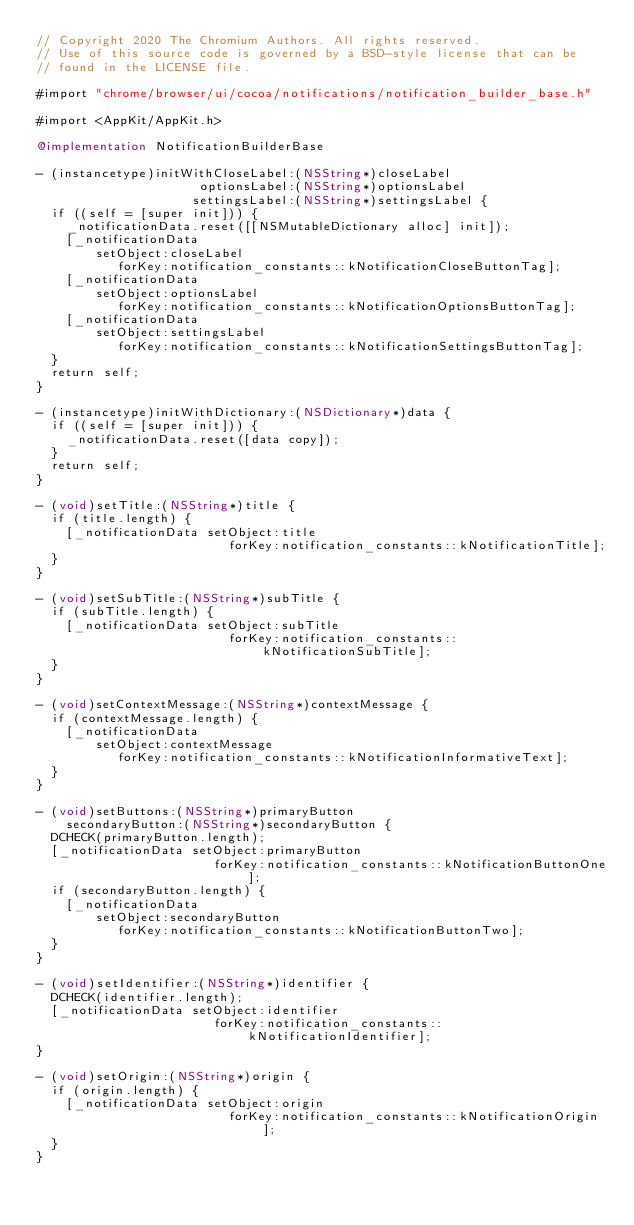Convert code to text. <code><loc_0><loc_0><loc_500><loc_500><_ObjectiveC_>// Copyright 2020 The Chromium Authors. All rights reserved.
// Use of this source code is governed by a BSD-style license that can be
// found in the LICENSE file.

#import "chrome/browser/ui/cocoa/notifications/notification_builder_base.h"

#import <AppKit/AppKit.h>

@implementation NotificationBuilderBase

- (instancetype)initWithCloseLabel:(NSString*)closeLabel
                      optionsLabel:(NSString*)optionsLabel
                     settingsLabel:(NSString*)settingsLabel {
  if ((self = [super init])) {
    _notificationData.reset([[NSMutableDictionary alloc] init]);
    [_notificationData
        setObject:closeLabel
           forKey:notification_constants::kNotificationCloseButtonTag];
    [_notificationData
        setObject:optionsLabel
           forKey:notification_constants::kNotificationOptionsButtonTag];
    [_notificationData
        setObject:settingsLabel
           forKey:notification_constants::kNotificationSettingsButtonTag];
  }
  return self;
}

- (instancetype)initWithDictionary:(NSDictionary*)data {
  if ((self = [super init])) {
    _notificationData.reset([data copy]);
  }
  return self;
}

- (void)setTitle:(NSString*)title {
  if (title.length) {
    [_notificationData setObject:title
                          forKey:notification_constants::kNotificationTitle];
  }
}

- (void)setSubTitle:(NSString*)subTitle {
  if (subTitle.length) {
    [_notificationData setObject:subTitle
                          forKey:notification_constants::kNotificationSubTitle];
  }
}

- (void)setContextMessage:(NSString*)contextMessage {
  if (contextMessage.length) {
    [_notificationData
        setObject:contextMessage
           forKey:notification_constants::kNotificationInformativeText];
  }
}

- (void)setButtons:(NSString*)primaryButton
    secondaryButton:(NSString*)secondaryButton {
  DCHECK(primaryButton.length);
  [_notificationData setObject:primaryButton
                        forKey:notification_constants::kNotificationButtonOne];
  if (secondaryButton.length) {
    [_notificationData
        setObject:secondaryButton
           forKey:notification_constants::kNotificationButtonTwo];
  }
}

- (void)setIdentifier:(NSString*)identifier {
  DCHECK(identifier.length);
  [_notificationData setObject:identifier
                        forKey:notification_constants::kNotificationIdentifier];
}

- (void)setOrigin:(NSString*)origin {
  if (origin.length) {
    [_notificationData setObject:origin
                          forKey:notification_constants::kNotificationOrigin];
  }
}
</code> 